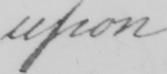Please provide the text content of this handwritten line. upon 